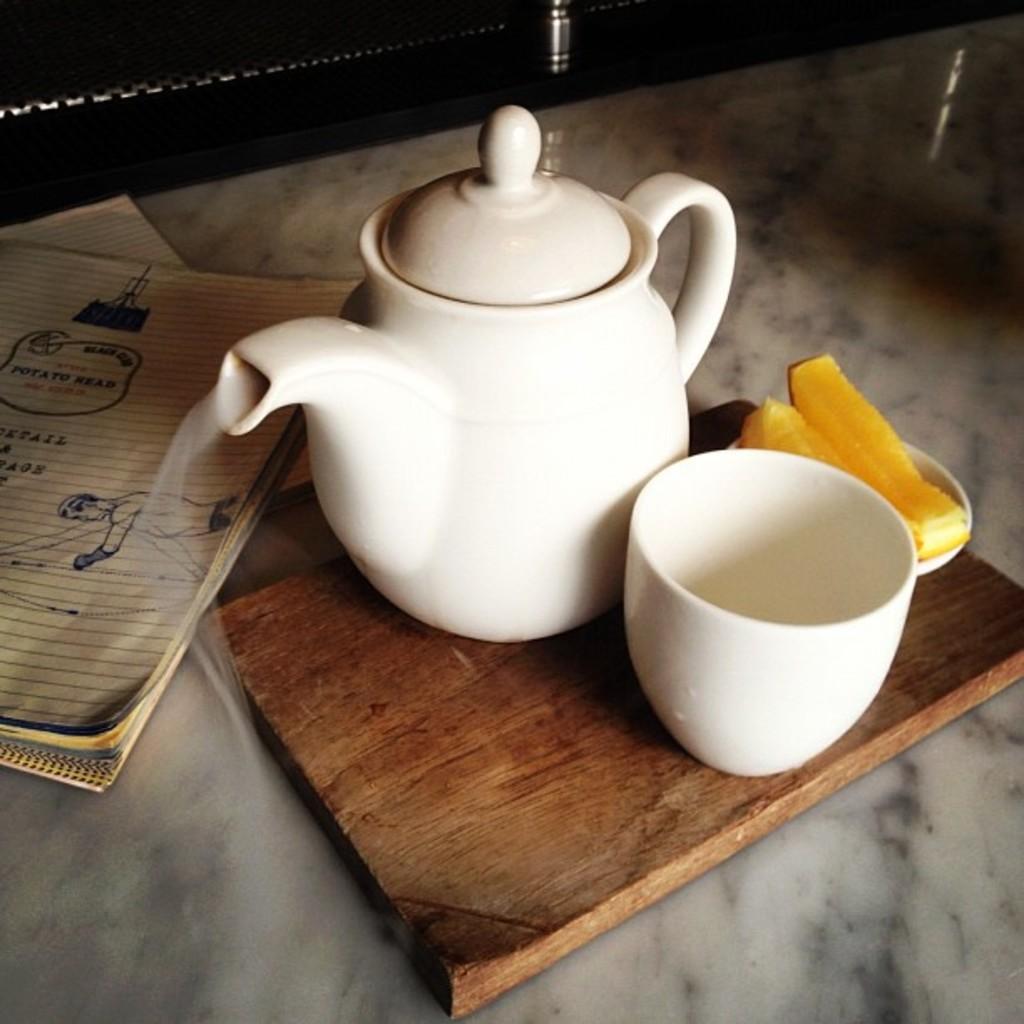How would you summarize this image in a sentence or two? In this picture we can see floor and on floor we have book, wooden plank and on wooden plank there is tea pot, cup, plate some food in it. 